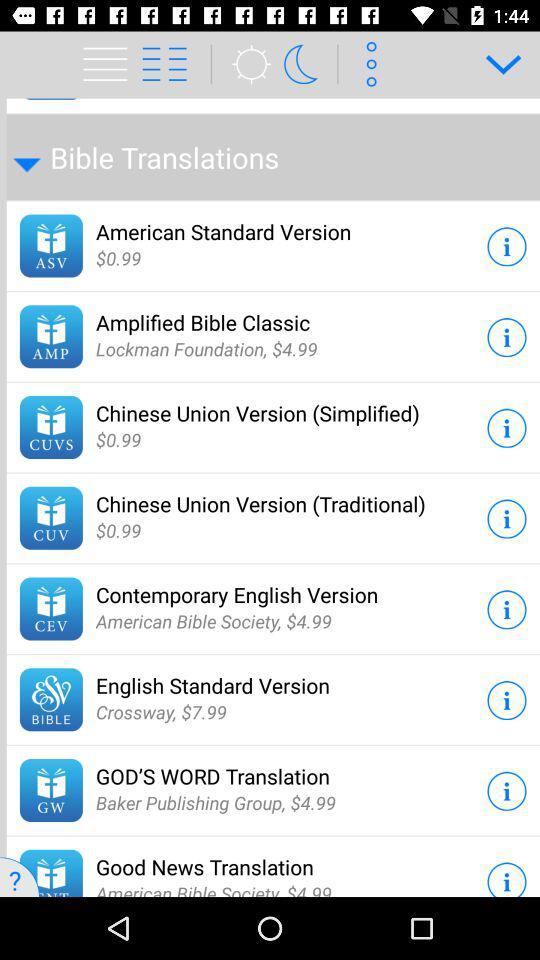How many Bible translations have a price tag of $4.99?
Answer the question using a single word or phrase. 4 